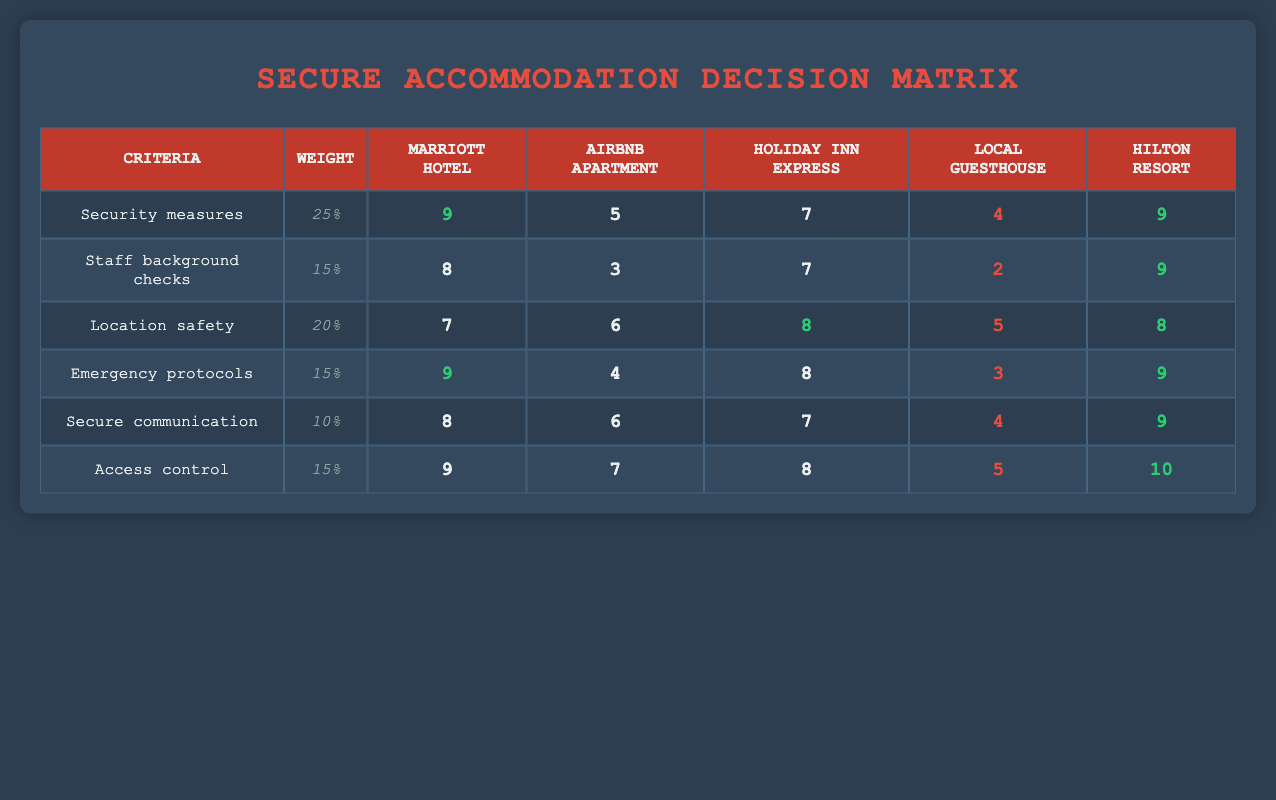What is the highest rating for security measures among the accommodations listed? The highest rating for security measures can be found by comparing the security measures scores of each accommodation in the first row. Both the Marriott Hotel and Hilton Resort have a score of 9, which is the maximum in that category.
Answer: 9 Which accommodation has the lowest rating for staff background checks? By looking at the staff background checks ratings in the second row, the Local guesthouse has the lowest rating of 2.
Answer: 2 What is the average rating for location safety across all options? To calculate the average, sum the ratings for location safety: (7 + 6 + 8 + 5 + 8) = 34. There are 5 accommodations, so the average is 34/5 = 6.8.
Answer: 6.8 Is the Airbnb apartment's rating for emergency protocols higher than its rating for secure communication? The rating for emergency protocols is 4, while the rating for secure communication is 6. Since 4 is not greater than 6, the answer is no.
Answer: No Which accommodation has the best overall access control rating? The ratings for access control in the last row show that the Hilton Resort has the highest score of 10, which is the top rating for that criterion.
Answer: 10 What is the difference in security measures ratings between the Marriott Hotel and the Local guesthouse? The Marriott Hotel has a rating of 9, while the Local guesthouse has a rating of 4. The difference is calculated as 9 - 4 = 5.
Answer: 5 Is the Holiday Inn Express safer in terms of location safety than the Airbnb apartment? The ratings indicate that the Holiday Inn Express has a location safety rating of 8, while the Airbnb apartment has a rating of 6. Since 8 is greater than 6, the answer is yes.
Answer: Yes Which accommodation has the highest overall score for emergency protocols and secure communication combined? The ratings for emergency protocols and secure communication must be gathered for each accommodation. Adding them together: Marriott Hotel (9 + 8), Airbnb apartment (4 + 6), Holiday Inn Express (8 + 7), Local guesthouse (3 + 4), Hilton Resort (9 + 9). The totals are Marriott Hotel (17), Airbnb apartment (10), Holiday Inn Express (15), Local guesthouse (7), Hilton Resort (18). The Hilton Resort has the highest combined total of 18.
Answer: Hilton Resort 